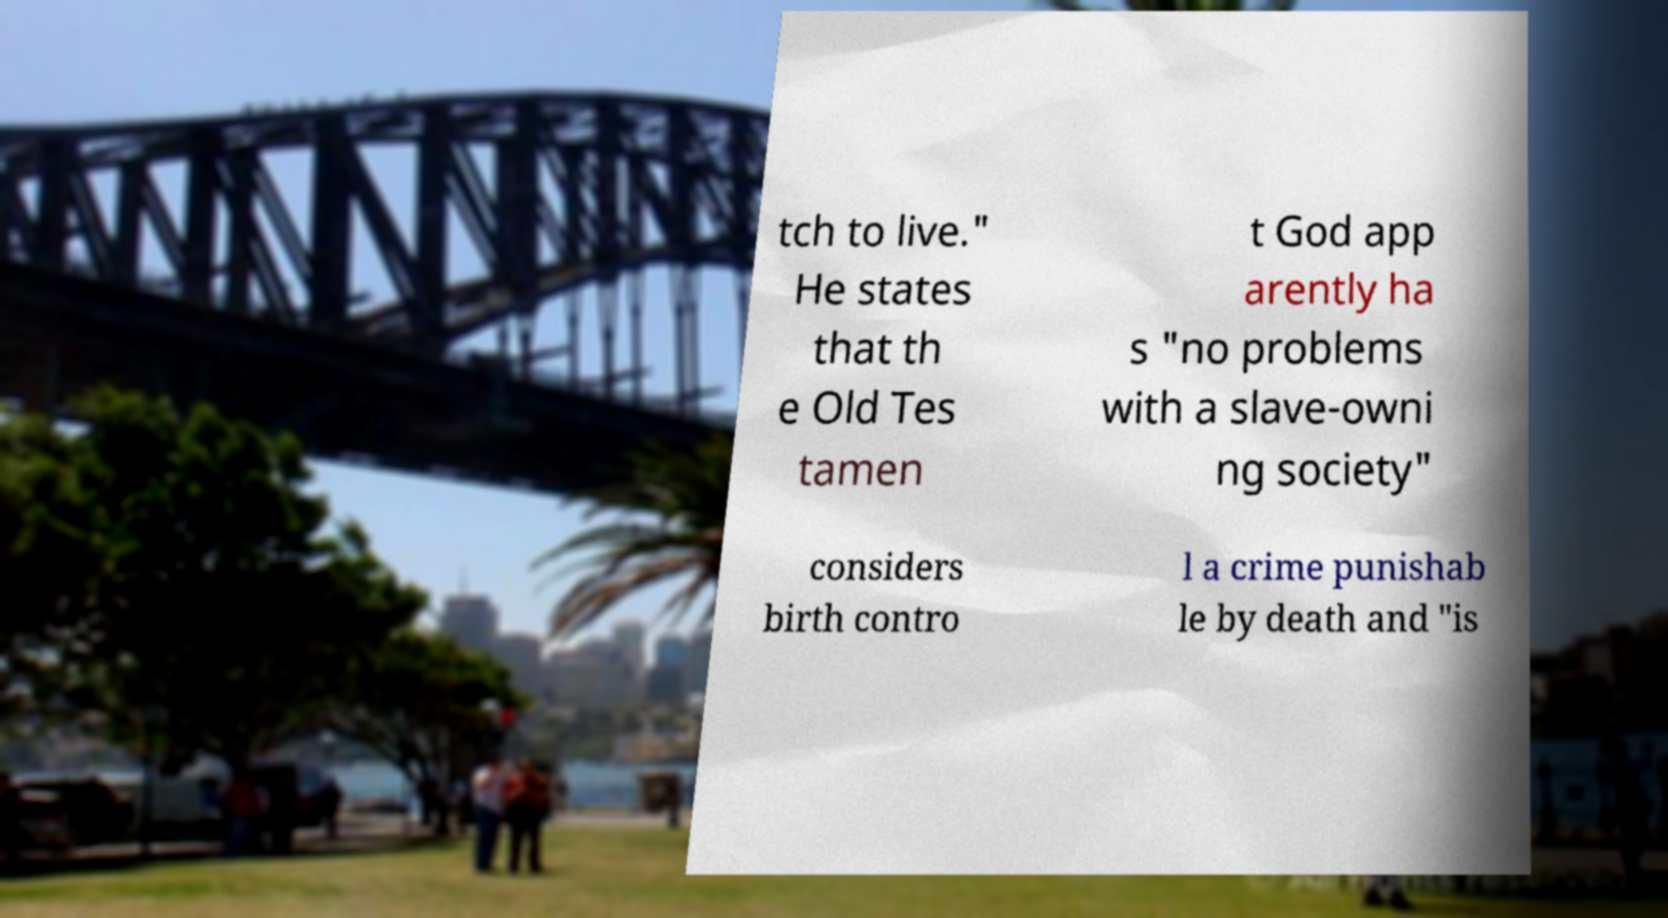Please read and relay the text visible in this image. What does it say? tch to live." He states that th e Old Tes tamen t God app arently ha s "no problems with a slave-owni ng society" considers birth contro l a crime punishab le by death and "is 